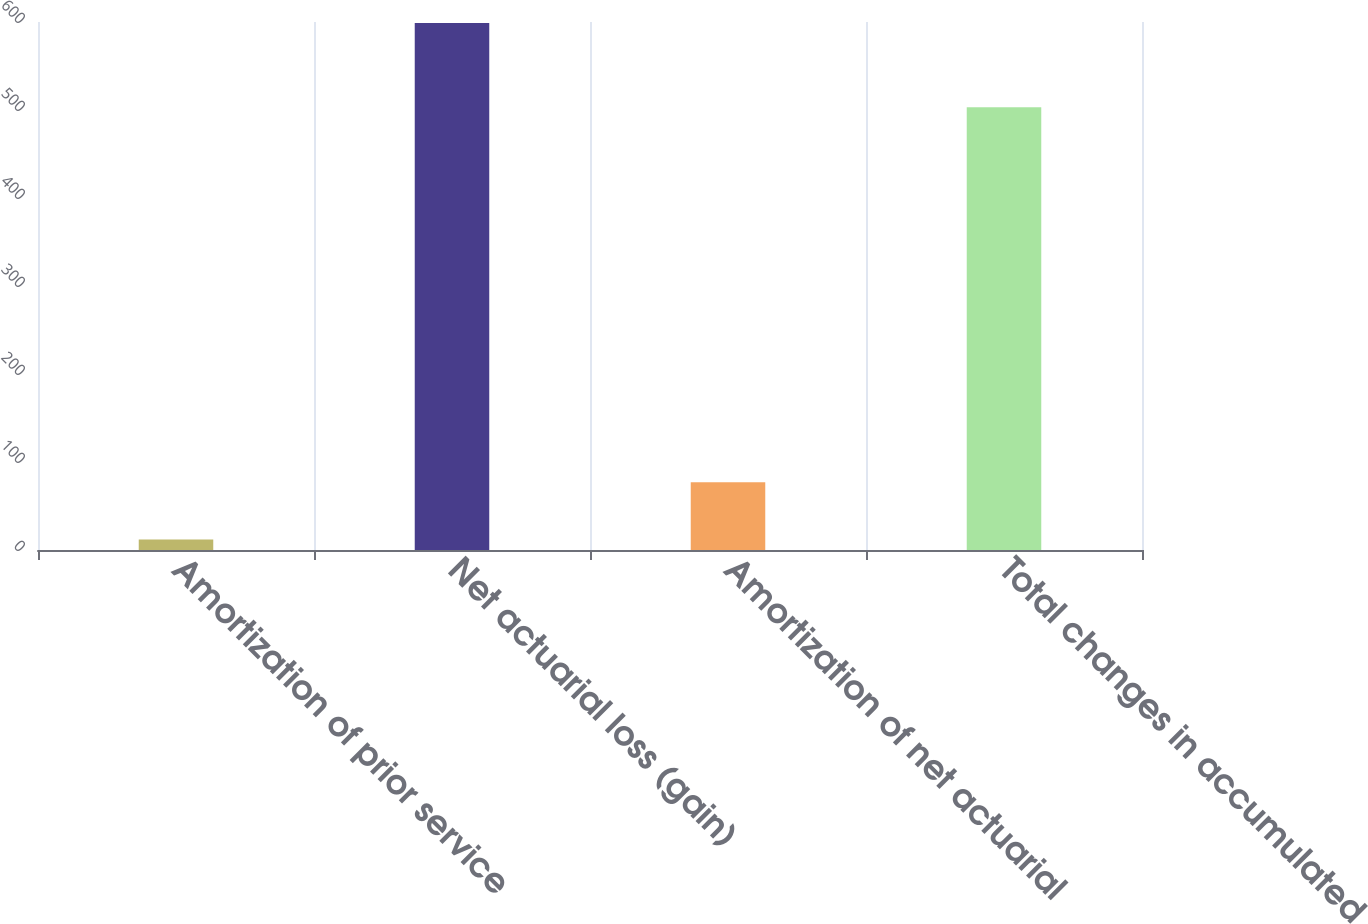Convert chart to OTSL. <chart><loc_0><loc_0><loc_500><loc_500><bar_chart><fcel>Amortization of prior service<fcel>Net actuarial loss (gain)<fcel>Amortization of net actuarial<fcel>Total changes in accumulated<nl><fcel>12<fcel>599<fcel>77<fcel>503<nl></chart> 